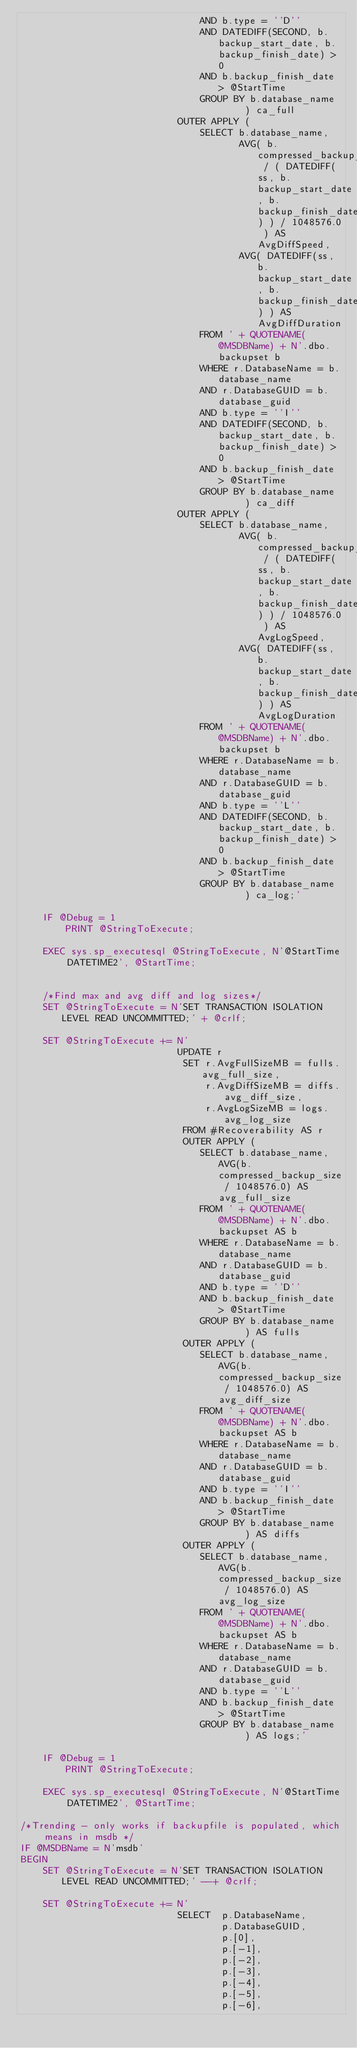<code> <loc_0><loc_0><loc_500><loc_500><_SQL_>								AND b.type = ''D'' 
								AND DATEDIFF(SECOND, b.backup_start_date, b.backup_finish_date) > 0
								AND b.backup_finish_date > @StartTime
								GROUP BY b.database_name
										) ca_full
							OUTER APPLY (
								SELECT b.database_name, 
									   AVG( b.compressed_backup_size / ( DATEDIFF(ss, b.backup_start_date, b.backup_finish_date) ) / 1048576.0 ) AS AvgDiffSpeed,
									   AVG( DATEDIFF(ss, b.backup_start_date, b.backup_finish_date) ) AS AvgDiffDuration
								FROM ' + QUOTENAME(@MSDBName) + N'.dbo.backupset b
								WHERE r.DatabaseName = b.database_name
								AND r.DatabaseGUID = b.database_guid
								AND b.type = ''I'' 
								AND DATEDIFF(SECOND, b.backup_start_date, b.backup_finish_date) > 0
								AND b.backup_finish_date > @StartTime
								GROUP BY b.database_name
										) ca_diff
							OUTER APPLY (
								SELECT b.database_name, 
									   AVG( b.compressed_backup_size / ( DATEDIFF(ss, b.backup_start_date, b.backup_finish_date) ) / 1048576.0 ) AS AvgLogSpeed,
									   AVG( DATEDIFF(ss, b.backup_start_date, b.backup_finish_date) ) AS AvgLogDuration
								FROM ' + QUOTENAME(@MSDBName) + N'.dbo.backupset b
								WHERE r.DatabaseName = b.database_name
								AND r.DatabaseGUID = b.database_guid
								AND b.type = ''L''
								AND DATEDIFF(SECOND, b.backup_start_date, b.backup_finish_date) > 0
								AND b.backup_finish_date > @StartTime
								GROUP BY b.database_name
										) ca_log;'

	IF @Debug = 1
		PRINT @StringToExecute;

	EXEC sys.sp_executesql @StringToExecute, N'@StartTime DATETIME2', @StartTime;


	/*Find max and avg diff and log sizes*/
	SET @StringToExecute = N'SET TRANSACTION ISOLATION LEVEL READ UNCOMMITTED;' + @crlf;

	SET @StringToExecute += N'
							UPDATE r
							 SET r.AvgFullSizeMB = fulls.avg_full_size,
							 	 r.AvgDiffSizeMB = diffs.avg_diff_size,
							 	 r.AvgLogSizeMB = logs.avg_log_size
							 FROM #Recoverability AS r
							 OUTER APPLY (
							 	SELECT b.database_name, AVG(b.compressed_backup_size / 1048576.0) AS avg_full_size
							 	FROM ' + QUOTENAME(@MSDBName) + N'.dbo.backupset AS b
							 	WHERE r.DatabaseName = b.database_name
								AND r.DatabaseGUID = b.database_guid
							 	AND b.type = ''D''
								AND b.backup_finish_date > @StartTime
							 	GROUP BY b.database_name
							 			) AS fulls
							 OUTER APPLY (
							 	SELECT b.database_name, AVG(b.compressed_backup_size / 1048576.0) AS avg_diff_size
							 	FROM ' + QUOTENAME(@MSDBName) + N'.dbo.backupset AS b
							 	WHERE r.DatabaseName = b.database_name
								AND r.DatabaseGUID = b.database_guid
							 	AND b.type = ''I''
								AND b.backup_finish_date > @StartTime
							 	GROUP BY b.database_name
							 			) AS diffs
							 OUTER APPLY (
							 	SELECT b.database_name, AVG(b.compressed_backup_size / 1048576.0) AS avg_log_size
							 	FROM ' + QUOTENAME(@MSDBName) + N'.dbo.backupset AS b
							 	WHERE r.DatabaseName = b.database_name
								AND r.DatabaseGUID = b.database_guid
							 	AND b.type = ''L''
								AND b.backup_finish_date > @StartTime
							 	GROUP BY b.database_name
							 			) AS logs;'

	IF @Debug = 1
		PRINT @StringToExecute;

	EXEC sys.sp_executesql @StringToExecute, N'@StartTime DATETIME2', @StartTime;
	
/*Trending - only works if backupfile is populated, which means in msdb */
IF @MSDBName = N'msdb'
BEGIN
	SET @StringToExecute = N'SET TRANSACTION ISOLATION LEVEL READ UNCOMMITTED;' --+ @crlf;

	SET @StringToExecute += N'
							SELECT  p.DatabaseName,
									p.DatabaseGUID,
									p.[0],
									p.[-1],
									p.[-2],
									p.[-3],
									p.[-4],
									p.[-5],
									p.[-6],</code> 